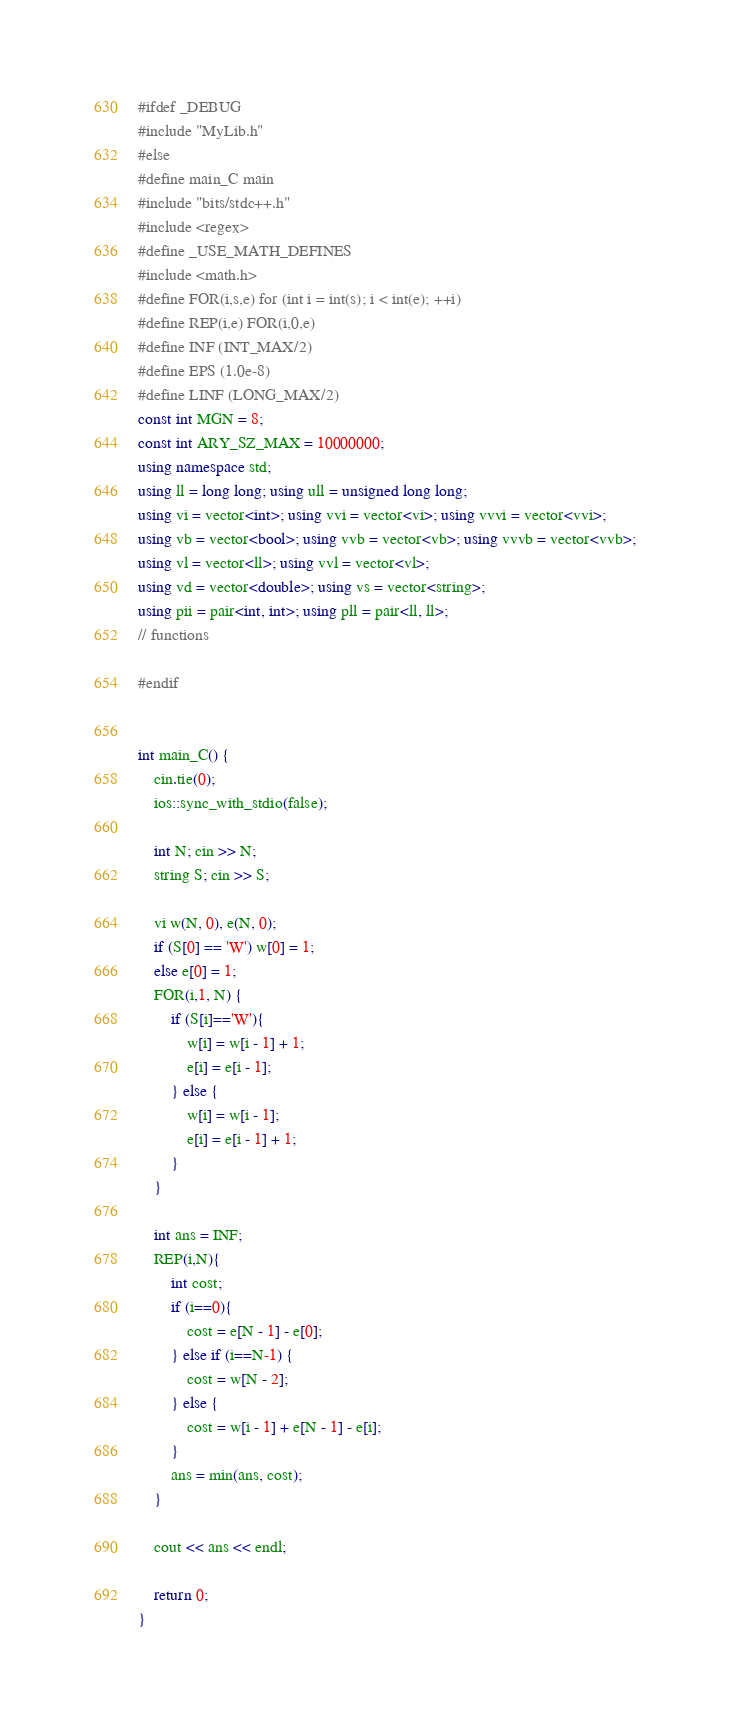Convert code to text. <code><loc_0><loc_0><loc_500><loc_500><_C++_>#ifdef _DEBUG
#include "MyLib.h"
#else
#define main_C main
#include "bits/stdc++.h"
#include <regex>
#define _USE_MATH_DEFINES
#include <math.h>
#define FOR(i,s,e) for (int i = int(s); i < int(e); ++i)
#define REP(i,e) FOR(i,0,e)
#define INF (INT_MAX/2)
#define EPS (1.0e-8)
#define LINF (LONG_MAX/2)
const int MGN = 8;
const int ARY_SZ_MAX = 10000000;
using namespace std;
using ll = long long; using ull = unsigned long long;
using vi = vector<int>; using vvi = vector<vi>; using vvvi = vector<vvi>;
using vb = vector<bool>; using vvb = vector<vb>; using vvvb = vector<vvb>;
using vl = vector<ll>; using vvl = vector<vl>;
using vd = vector<double>; using vs = vector<string>;
using pii = pair<int, int>; using pll = pair<ll, ll>;
// functions

#endif


int main_C() {
    cin.tie(0);
    ios::sync_with_stdio(false);
    
    int N; cin >> N;
    string S; cin >> S;

    vi w(N, 0), e(N, 0);
    if (S[0] == 'W') w[0] = 1;
    else e[0] = 1;
    FOR(i,1, N) {
        if (S[i]=='W'){
            w[i] = w[i - 1] + 1;
            e[i] = e[i - 1];
        } else {
            w[i] = w[i - 1];
            e[i] = e[i - 1] + 1;
        }
    }

    int ans = INF;
    REP(i,N){
        int cost;
        if (i==0){
            cost = e[N - 1] - e[0];
        } else if (i==N-1) {
            cost = w[N - 2];
        } else {
            cost = w[i - 1] + e[N - 1] - e[i];
        }
        ans = min(ans, cost);
    }

    cout << ans << endl;

    return 0;
}</code> 